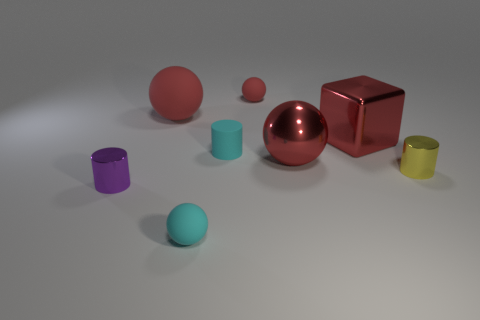Subtract all big red shiny spheres. How many spheres are left? 3 Subtract all red cylinders. How many red balls are left? 3 Add 1 large purple balls. How many objects exist? 9 Subtract all cyan spheres. How many spheres are left? 3 Subtract all cubes. How many objects are left? 7 Add 2 big purple matte objects. How many big purple matte objects exist? 2 Subtract 1 red cubes. How many objects are left? 7 Subtract all gray spheres. Subtract all green blocks. How many spheres are left? 4 Subtract all yellow objects. Subtract all tiny red spheres. How many objects are left? 6 Add 1 tiny red things. How many tiny red things are left? 2 